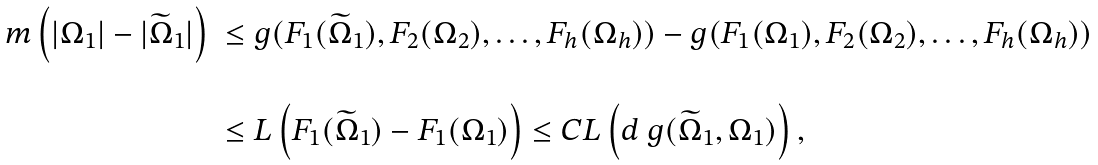Convert formula to latex. <formula><loc_0><loc_0><loc_500><loc_500>\begin{array} { l l } m \left ( | \Omega _ { 1 } | - | \widetilde { \Omega } _ { 1 } | \right ) & \leq g ( F _ { 1 } ( \widetilde { \Omega } _ { 1 } ) , F _ { 2 } ( \Omega _ { 2 } ) , \dots , F _ { h } ( \Omega _ { h } ) ) - g ( F _ { 1 } ( \Omega _ { 1 } ) , F _ { 2 } ( \Omega _ { 2 } ) , \dots , F _ { h } ( \Omega _ { h } ) ) \\ \\ & \leq L \left ( F _ { 1 } ( \widetilde { \Omega } _ { 1 } ) - F _ { 1 } ( \Omega _ { 1 } ) \right ) \leq C L \left ( d _ { \ } g ( \widetilde { \Omega } _ { 1 } , \Omega _ { 1 } ) \right ) , \end{array}</formula> 